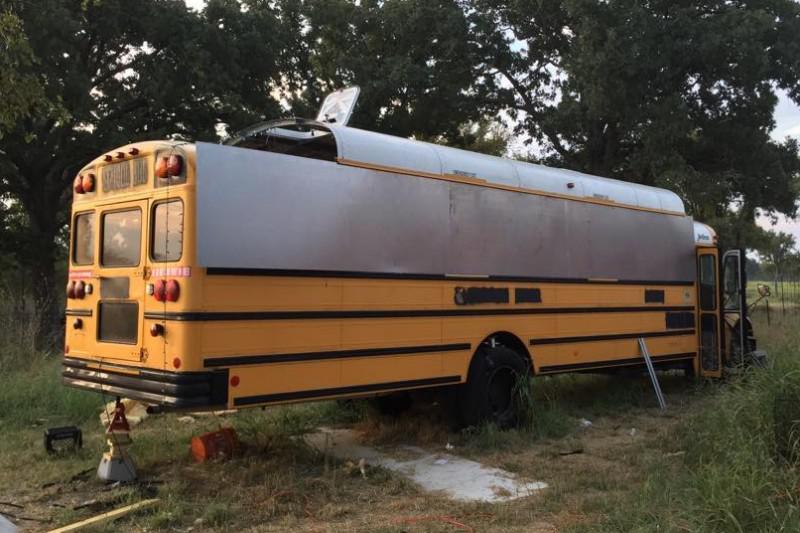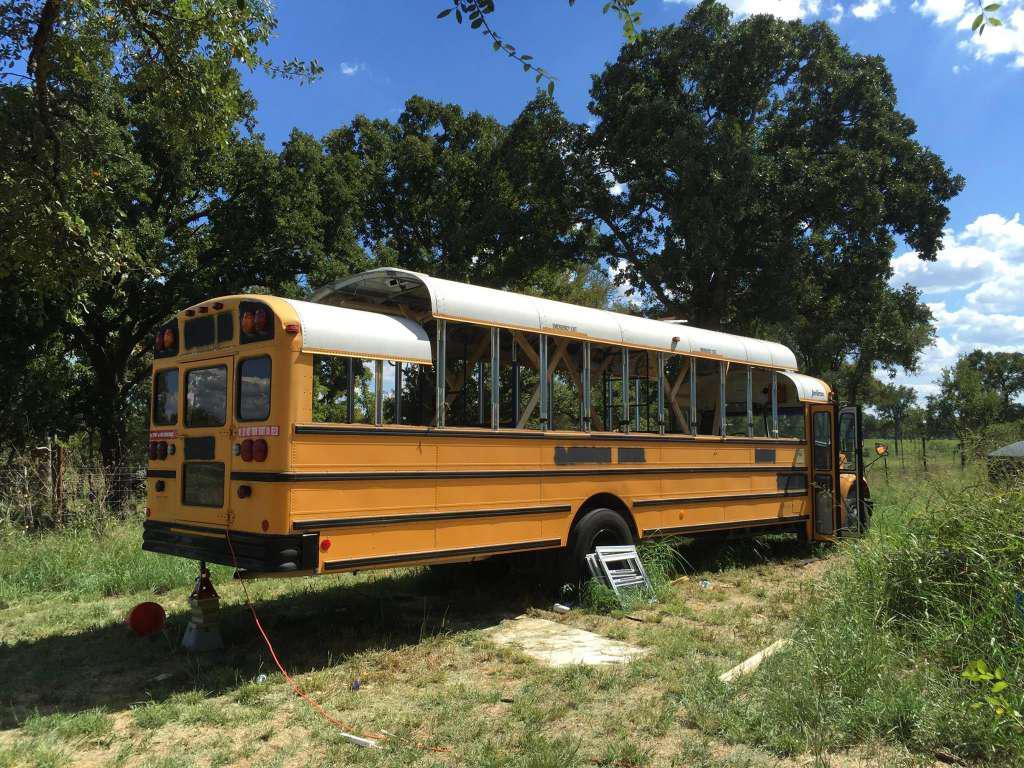The first image is the image on the left, the second image is the image on the right. Analyze the images presented: Is the assertion "Both buses are facing diagonally and to the same side." valid? Answer yes or no. Yes. The first image is the image on the left, the second image is the image on the right. Assess this claim about the two images: "Exactly one bus' doors are open.". Correct or not? Answer yes or no. No. 